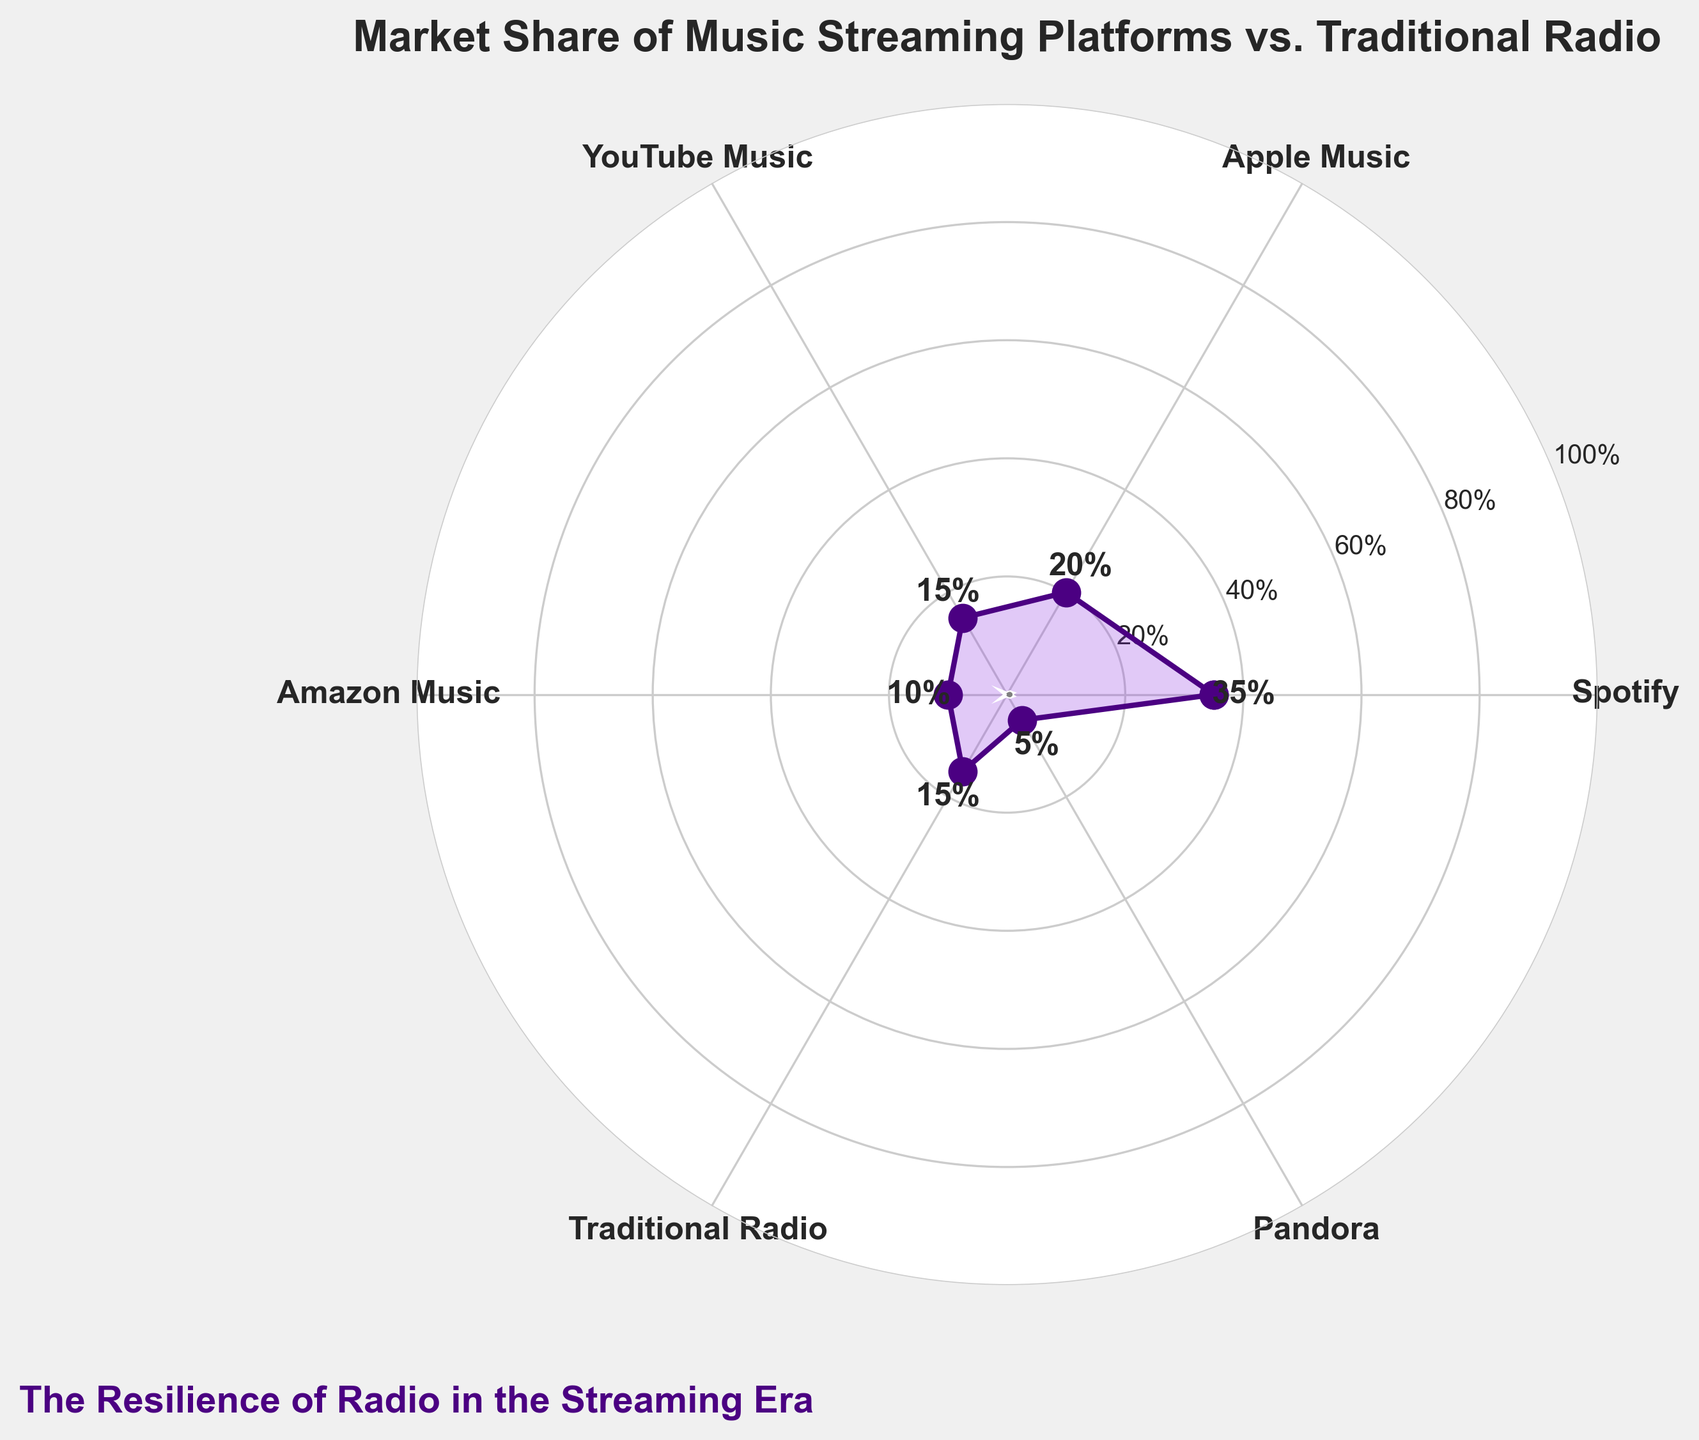What's the market share of Spotify? The chart indicates the percentage for each platform marked around the gauge. Locate the section labeled 'Spotify' to find its value.
Answer: 35% What is the total market share of YouTube Music and Pandora combined? Find the percentages for YouTube Music and Pandora, then sum them. YouTube Music: 15%, Pandora: 5%. 15% + 5% = 20%
Answer: 20% Is Apple Music's market share greater than Traditional Radio's? Compare the percentages shown for Apple Music and Traditional Radio. Apple Music: 20%, Traditional Radio: 15%. 20% > 15%.
Answer: Yes Which has a lower market share, Amazon Music or Pandora? Compare the percentages for Amazon Music and Pandora. Amazon Music: 10%, Pandora: 5%. 5% < 10%.
Answer: Pandora What's the difference in market share between the top platform and Traditional Radio? The top platform is Spotify with 35%. Traditional Radio has 15%. Calculate the difference: 35% - 15% = 20%
Answer: 20% How is the resilience of Traditional Radio demonstrated in this chart? Traditional Radio maintains a 15% market share, which is visually comparable to or greater than some streaming platforms like YouTube Music and Pandora, demonstrating its continued relevance.
Answer: 15% What is the average market share of the streaming platforms? Add the percentages for Spotify, Apple Music, YouTube Music, Amazon Music, and Pandora, then divide by 5. (35% + 20% + 15% + 10% + 5%) / 5. 85% / 5 = 17%
Answer: 17% How many platforms have a market share of less than 20%? Identify the sections labeled with percentages less than 20%. Look for YouTube Music (15%), Traditional Radio (15%), Amazon Music (10%), and Pandora (5%). There are 4 such platforms.
Answer: 4 What color is used to represent the wedge for the highest market share platform? The chart uses a color scale to differentiate between platforms. The wedge corresponding to the highest market share (Spotify) is visually identified to have a unique color.
Answer: Indigo (or similar shade used for Spotify) How does Traditional Radio compare to new streaming platforms in maintaining market share? Traditional Radio holds a 15% share, surpassing newer streaming services like Pandora (5%), and equalling YouTube Music (15%), indicating its enduring presence in the market.
Answer: Holds steady at 15% 